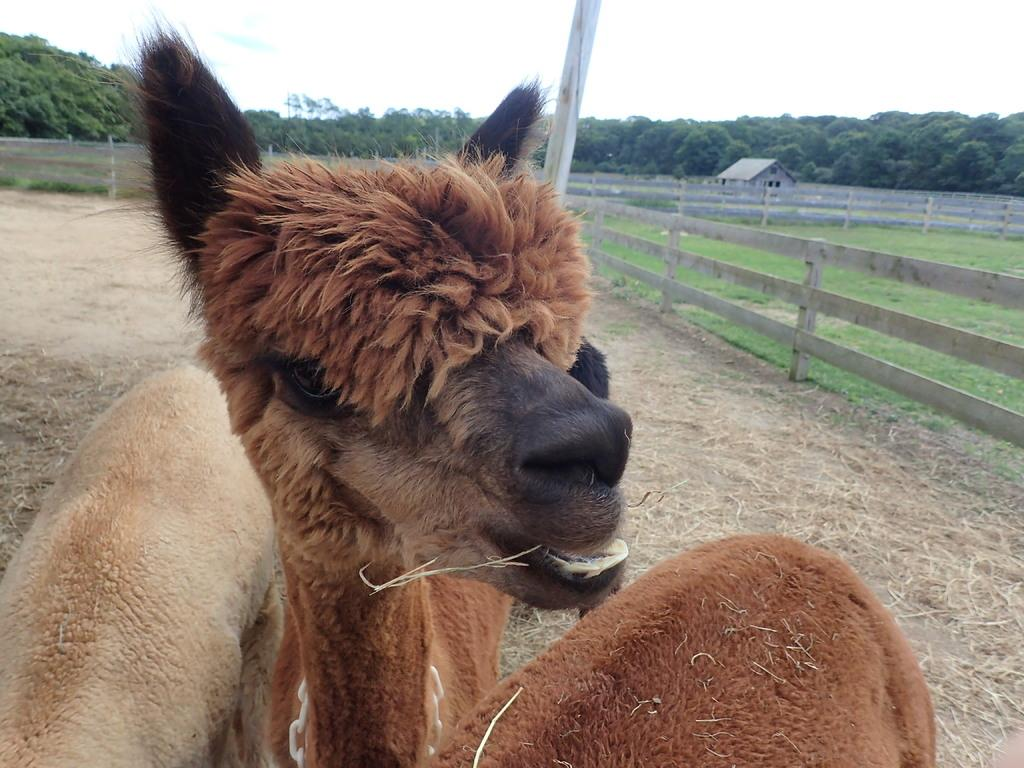What is located in the center of the image? There are animals in the center of the image. What can be seen in the background of the image? There is a fence, a shed, a pole, and many trees in the background of the image. What is visible at the bottom of the image? The ground is visible at the bottom of the image. What type of stew is being prepared on the sofa in the image? There is no stew or sofa present in the image. How many ducks are visible in the image? There is no duck present in the image. 